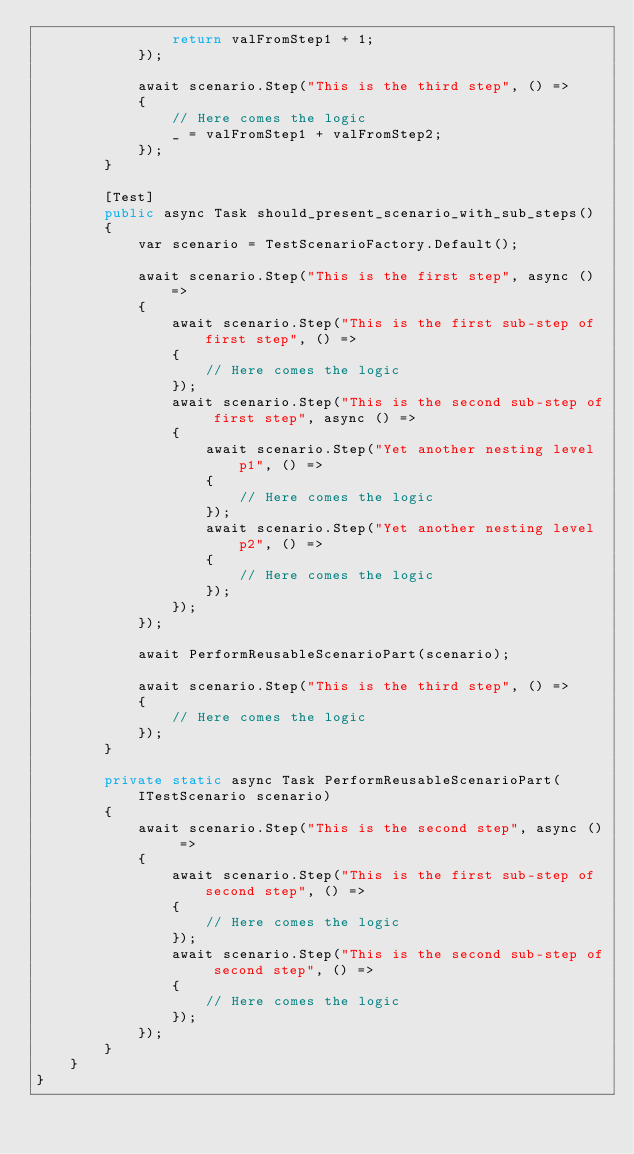<code> <loc_0><loc_0><loc_500><loc_500><_C#_>                return valFromStep1 + 1;
            });

            await scenario.Step("This is the third step", () =>
            {
                // Here comes the logic
                _ = valFromStep1 + valFromStep2;
            });
        }
        
        [Test]
        public async Task should_present_scenario_with_sub_steps()
        {
            var scenario = TestScenarioFactory.Default();

            await scenario.Step("This is the first step", async () =>
            {
                await scenario.Step("This is the first sub-step of first step", () =>
                {
                    // Here comes the logic
                });
                await scenario.Step("This is the second sub-step of first step", async () =>
                {
                    await scenario.Step("Yet another nesting level p1", () =>
                    {
                        // Here comes the logic
                    });
                    await scenario.Step("Yet another nesting level p2", () =>
                    {
                        // Here comes the logic
                    });
                });
            });
            
            await PerformReusableScenarioPart(scenario);
            
            await scenario.Step("This is the third step", () =>
            {
                // Here comes the logic
            });
        }

        private static async Task PerformReusableScenarioPart(ITestScenario scenario)
        {
            await scenario.Step("This is the second step", async () =>
            {
                await scenario.Step("This is the first sub-step of second step", () =>
                {
                    // Here comes the logic
                });
                await scenario.Step("This is the second sub-step of second step", () =>
                {
                    // Here comes the logic
                });
            });
        }
    }
}</code> 